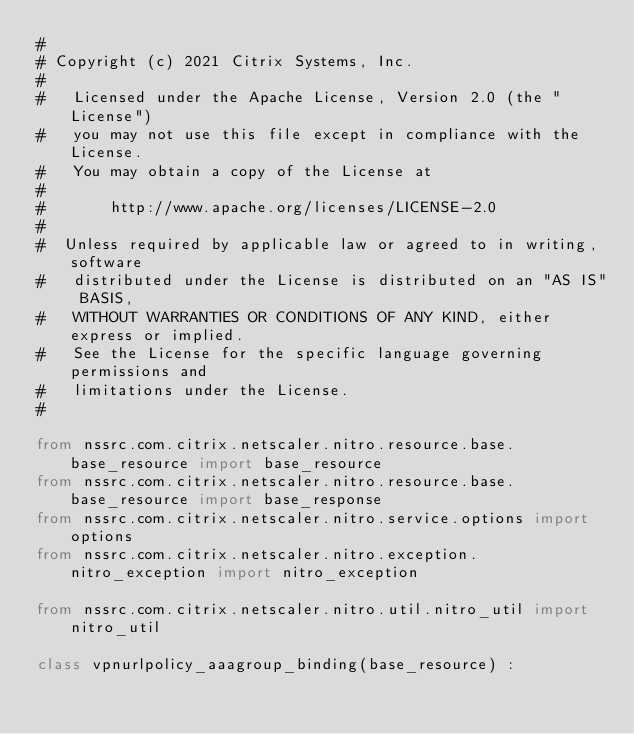<code> <loc_0><loc_0><loc_500><loc_500><_Python_>#
# Copyright (c) 2021 Citrix Systems, Inc.
#
#   Licensed under the Apache License, Version 2.0 (the "License")
#   you may not use this file except in compliance with the License.
#   You may obtain a copy of the License at
#
#       http://www.apache.org/licenses/LICENSE-2.0
#
#  Unless required by applicable law or agreed to in writing, software
#   distributed under the License is distributed on an "AS IS" BASIS,
#   WITHOUT WARRANTIES OR CONDITIONS OF ANY KIND, either express or implied.
#   See the License for the specific language governing permissions and
#   limitations under the License.
#

from nssrc.com.citrix.netscaler.nitro.resource.base.base_resource import base_resource
from nssrc.com.citrix.netscaler.nitro.resource.base.base_resource import base_response
from nssrc.com.citrix.netscaler.nitro.service.options import options
from nssrc.com.citrix.netscaler.nitro.exception.nitro_exception import nitro_exception

from nssrc.com.citrix.netscaler.nitro.util.nitro_util import nitro_util

class vpnurlpolicy_aaagroup_binding(base_resource) :</code> 